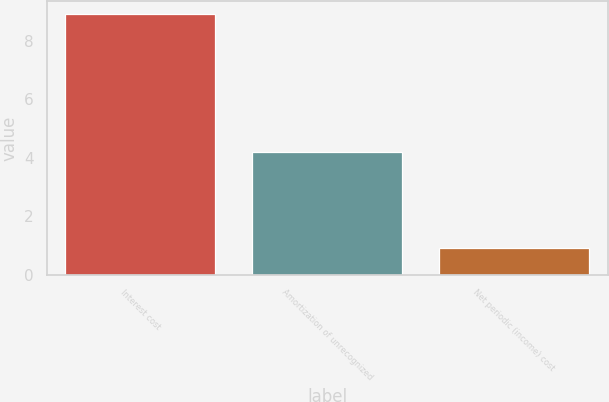Convert chart to OTSL. <chart><loc_0><loc_0><loc_500><loc_500><bar_chart><fcel>Interest cost<fcel>Amortization of unrecognized<fcel>Net periodic (income) cost<nl><fcel>8.9<fcel>4.2<fcel>0.9<nl></chart> 